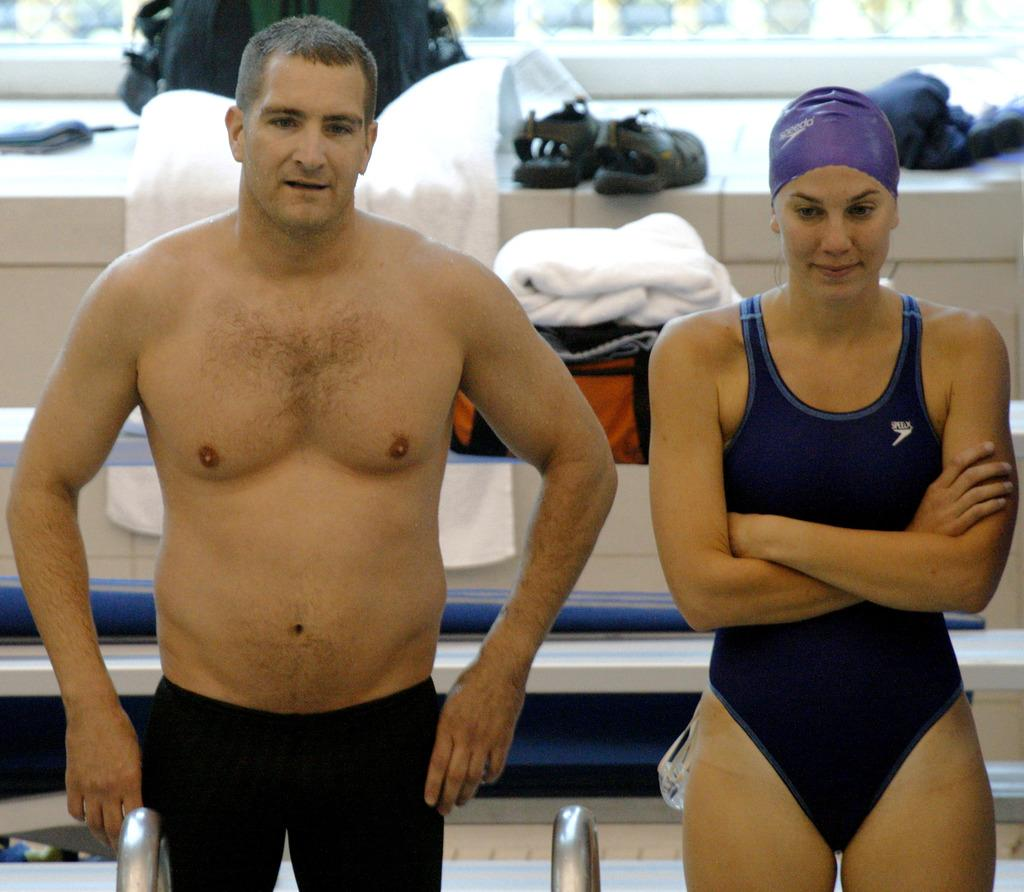How many people are in the image? There is a man and a woman in the image. What are the man and woman doing in the image? The man and woman are standing. What can be seen in the background of the image? There are steps in the background of the image. What items are on the steps? Clothes, bags, and slippers are visible on the steps. What is in front of the man? There are two iron poles in front of the man. What type of toy can be heard making noise in the image? There is no toy present in the image, and therefore no such noise can be heard. 